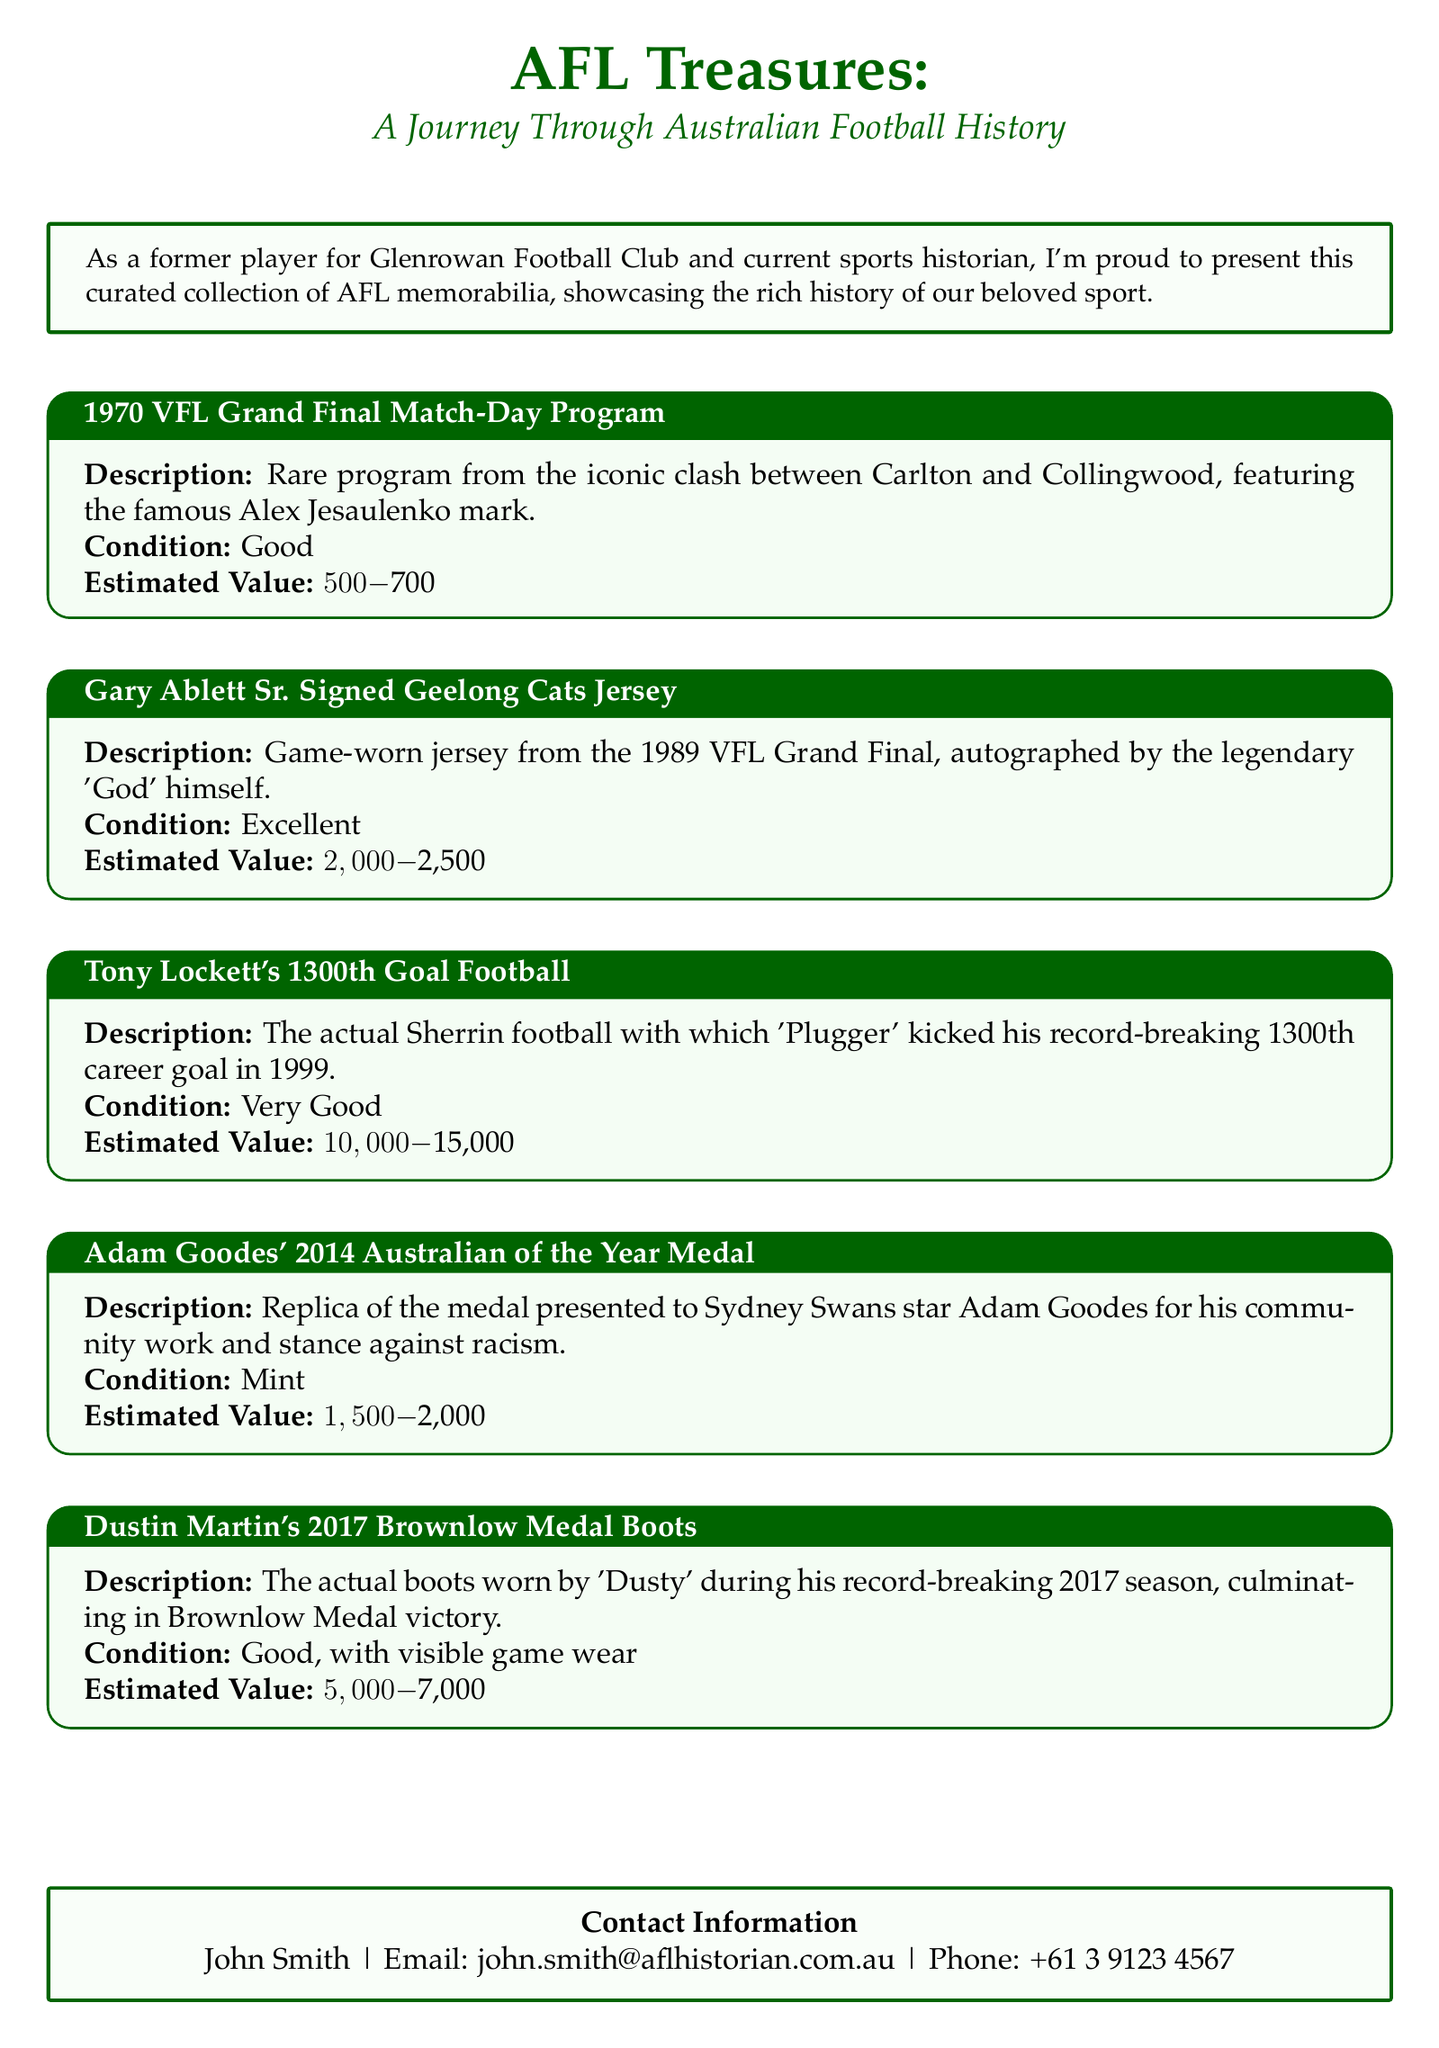What is the title of the catalog? The title is prominently displayed at the top of the document, highlighting the focal subject of the collection.
Answer: AFL Treasures Who signed the jersey featured in the catalog? The document lists the jersey's significant individual, showcasing the memorabilia's value and history.
Answer: Gary Ablett Sr What is the estimated value of Tony Lockett's 1300th Goal Football? This information can be found near the description of the item, providing insight into its value within the collection.
Answer: $10,000-$15,000 In what year did Adam Goodes receive the Australian of the Year Medal? The document mentions the year related to the medal, which is significant for understanding the context of the memorabilia.
Answer: 2014 What condition is Dustin Martin's 2017 Brownlow Medal Boots in? The condition of the boots is specified, which is important for collectors and historians analyzing value and wear.
Answer: Good, with visible game wear Which match is associated with the 1970 VFL Grand Final Match-Day Program? This question focuses on the specific event tied to an item in the collection, revealing important historical context.
Answer: Carlton and Collingwood What type of item is described for Adam Goodes? Here, the question addresses the specific nature of the memorabilia, providing clarity on its significance.
Answer: Replica of the medal What is the contact email provided in the catalog? The catalog includes contact information, which is crucial for potential buyers and interested parties.
Answer: john.smith@aflhistorian.com.au 